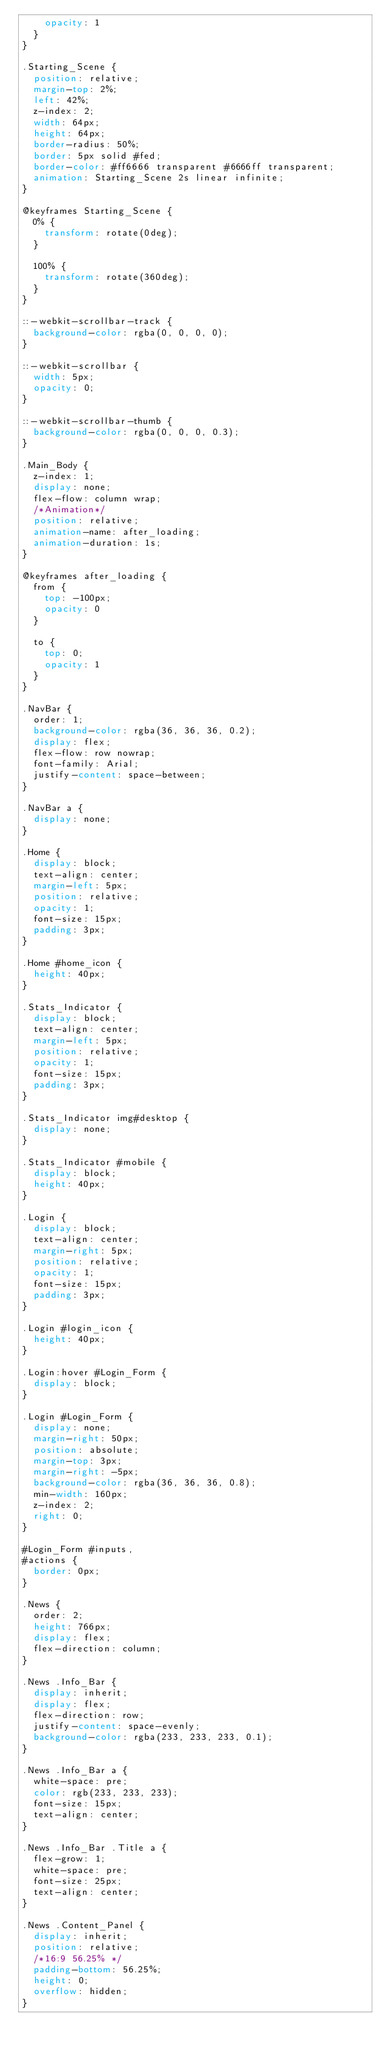Convert code to text. <code><loc_0><loc_0><loc_500><loc_500><_CSS_>    opacity: 1
  }
}

.Starting_Scene {
  position: relative;
  margin-top: 2%;
  left: 42%;
  z-index: 2;
  width: 64px;
  height: 64px;
  border-radius: 50%;
  border: 5px solid #fed;
  border-color: #ff6666 transparent #6666ff transparent;
  animation: Starting_Scene 2s linear infinite;
}

@keyframes Starting_Scene {
  0% {
    transform: rotate(0deg);
  }

  100% {
    transform: rotate(360deg);
  }
}

::-webkit-scrollbar-track {
  background-color: rgba(0, 0, 0, 0);
}

::-webkit-scrollbar {
  width: 5px;
  opacity: 0;
}

::-webkit-scrollbar-thumb {
  background-color: rgba(0, 0, 0, 0.3);
}

.Main_Body {
  z-index: 1;
  display: none;
  flex-flow: column wrap;
  /*Animation*/
  position: relative;
  animation-name: after_loading;
  animation-duration: 1s;
}

@keyframes after_loading {
  from {
    top: -100px;
    opacity: 0
  }

  to {
    top: 0;
    opacity: 1
  }
}

.NavBar {
  order: 1;
  background-color: rgba(36, 36, 36, 0.2);
  display: flex;
  flex-flow: row nowrap;
  font-family: Arial;
  justify-content: space-between;
}

.NavBar a {
  display: none;
}

.Home {
  display: block;
  text-align: center;
  margin-left: 5px;
  position: relative;
  opacity: 1;
  font-size: 15px;
  padding: 3px;
}

.Home #home_icon {
  height: 40px;
}

.Stats_Indicator {
  display: block;
  text-align: center;
  margin-left: 5px;
  position: relative;
  opacity: 1;
  font-size: 15px;
  padding: 3px;
}

.Stats_Indicator img#desktop {
  display: none;
}

.Stats_Indicator #mobile {
  display: block;
  height: 40px;
}

.Login {
  display: block;
  text-align: center;
  margin-right: 5px;
  position: relative;
  opacity: 1;
  font-size: 15px;
  padding: 3px;
}

.Login #login_icon {
  height: 40px;
}

.Login:hover #Login_Form {
  display: block;
}

.Login #Login_Form {
  display: none;
  margin-right: 50px;
  position: absolute;
  margin-top: 3px;
  margin-right: -5px;
  background-color: rgba(36, 36, 36, 0.8);
  min-width: 160px;
  z-index: 2;
  right: 0;
}

#Login_Form #inputs,
#actions {
  border: 0px;
}

.News {
  order: 2;
  height: 766px;
  display: flex;
  flex-direction: column;
}

.News .Info_Bar {
  display: inherit;
  display: flex;
  flex-direction: row;
  justify-content: space-evenly;
  background-color: rgba(233, 233, 233, 0.1);
}

.News .Info_Bar a {
  white-space: pre;
  color: rgb(233, 233, 233);
  font-size: 15px;
  text-align: center;
}

.News .Info_Bar .Title a {
  flex-grow: 1;
  white-space: pre;
  font-size: 25px;
  text-align: center;
}

.News .Content_Panel {
  display: inherit;
  position: relative;
  /*16:9 56.25% */
  padding-bottom: 56.25%;
  height: 0;
  overflow: hidden;
}
</code> 